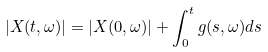<formula> <loc_0><loc_0><loc_500><loc_500>| X ( t , \omega ) | = | X ( 0 , \omega ) | + \int _ { 0 } ^ { t } g ( s , \omega ) d s</formula> 